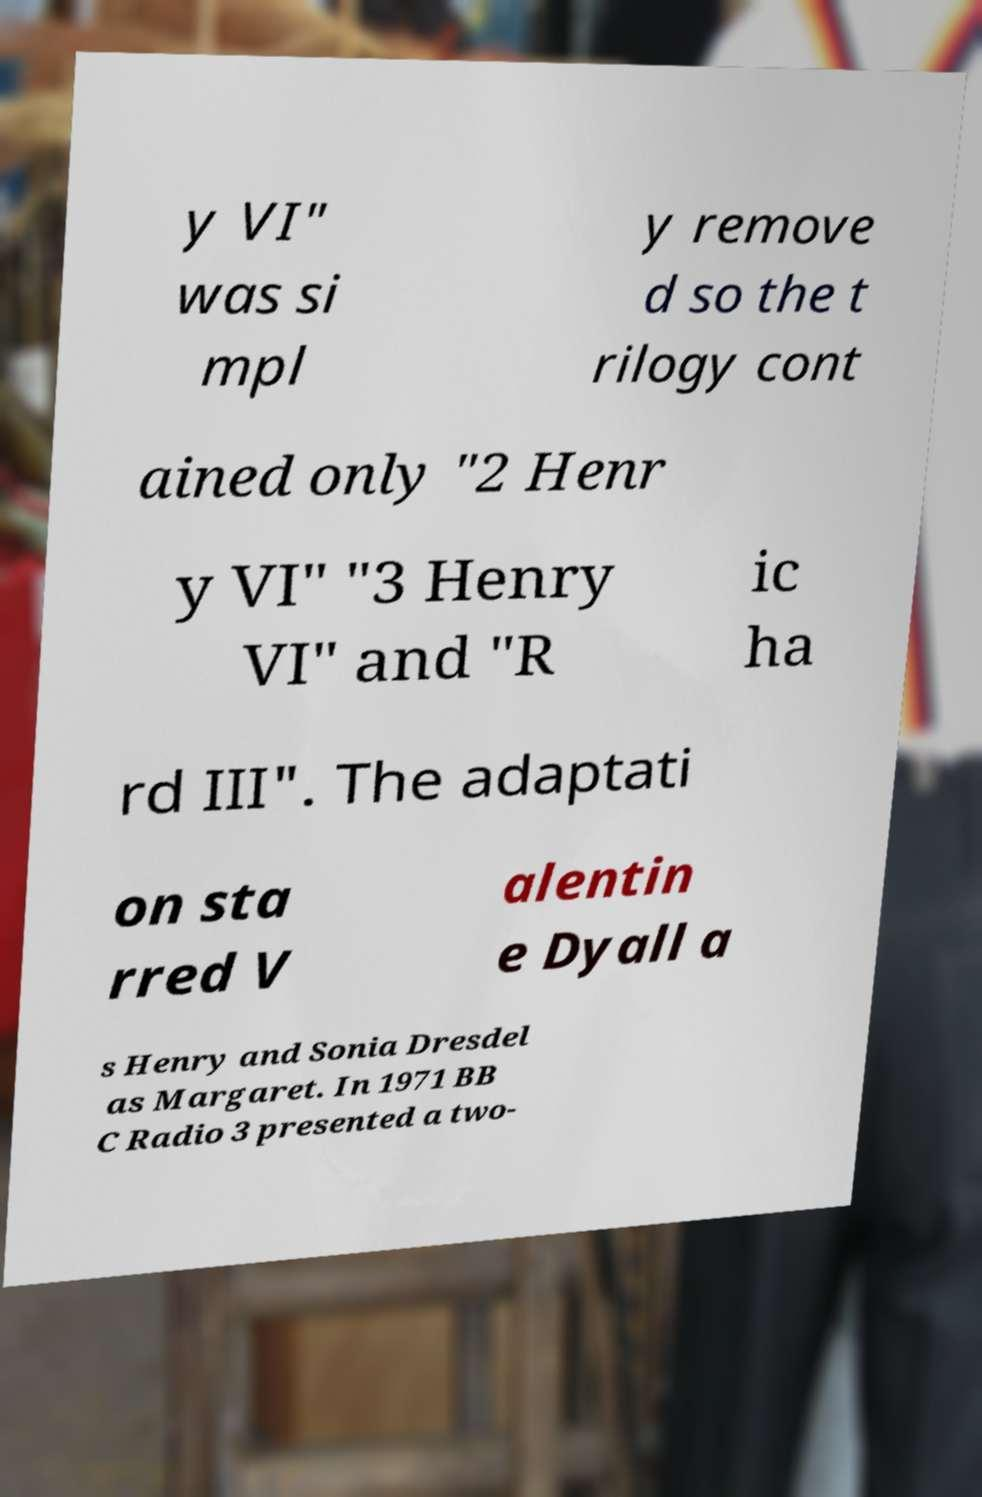What messages or text are displayed in this image? I need them in a readable, typed format. y VI" was si mpl y remove d so the t rilogy cont ained only "2 Henr y VI" "3 Henry VI" and "R ic ha rd III". The adaptati on sta rred V alentin e Dyall a s Henry and Sonia Dresdel as Margaret. In 1971 BB C Radio 3 presented a two- 